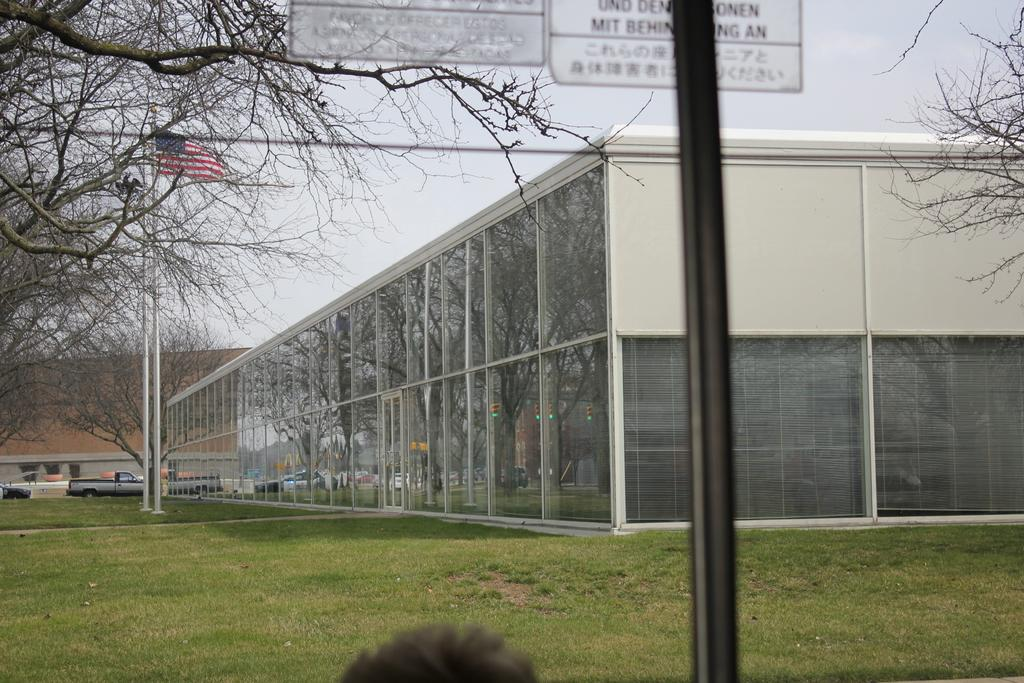What type of vegetation is present in the image? There is grass in the image. What structures can be seen in the image? There are poles, boards, a flag, trees, vehicles, and buildings in the image. What is visible in the background of the image? The sky is visible in the background of the image. What year is depicted in the image? The image does not depict a specific year; it is a still image of various objects and structures. Can you see any rays of light in the image? There are no rays of light visible in the image. 